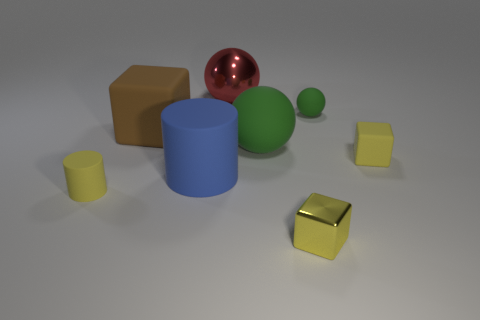What shape is the yellow matte object to the left of the shiny thing that is in front of the green object in front of the tiny ball?
Your answer should be very brief. Cylinder. How many things are either small rubber balls or tiny yellow blocks?
Keep it short and to the point. 3. Do the tiny matte thing to the left of the red ball and the green rubber object behind the brown matte cube have the same shape?
Your answer should be compact. No. How many yellow blocks are to the right of the tiny ball and to the left of the tiny green rubber ball?
Make the answer very short. 0. How many other things are the same size as the yellow metallic object?
Provide a short and direct response. 3. The ball that is in front of the large metallic thing and left of the yellow metallic object is made of what material?
Provide a succinct answer. Rubber. There is a small matte block; is its color the same as the matte cube to the left of the metal block?
Provide a short and direct response. No. The other matte thing that is the same shape as the big green object is what size?
Keep it short and to the point. Small. There is a thing that is both behind the brown rubber object and left of the yellow metallic object; what shape is it?
Provide a short and direct response. Sphere. There is a yellow cylinder; does it have the same size as the cylinder that is to the right of the small rubber cylinder?
Your answer should be compact. No. 